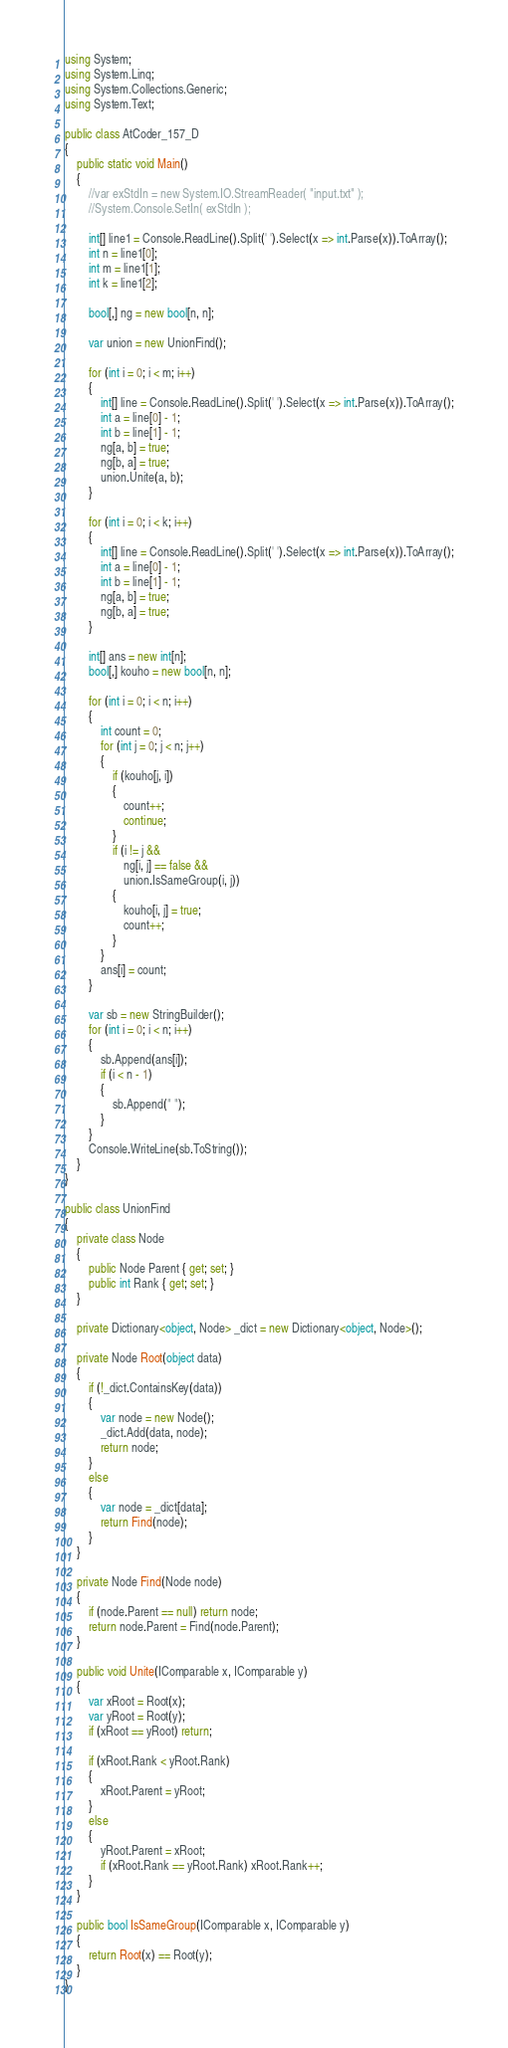<code> <loc_0><loc_0><loc_500><loc_500><_C#_>using System;
using System.Linq;
using System.Collections.Generic;
using System.Text;

public class AtCoder_157_D
{
    public static void Main()
    {
        //var exStdIn = new System.IO.StreamReader( "input.txt" );
        //System.Console.SetIn( exStdIn );

        int[] line1 = Console.ReadLine().Split(' ').Select(x => int.Parse(x)).ToArray();
        int n = line1[0];
        int m = line1[1];
        int k = line1[2];

        bool[,] ng = new bool[n, n];

        var union = new UnionFind();

        for (int i = 0; i < m; i++)
        {
            int[] line = Console.ReadLine().Split(' ').Select(x => int.Parse(x)).ToArray();
            int a = line[0] - 1;
            int b = line[1] - 1;
            ng[a, b] = true;
            ng[b, a] = true;
            union.Unite(a, b);
        }

        for (int i = 0; i < k; i++)
        {
            int[] line = Console.ReadLine().Split(' ').Select(x => int.Parse(x)).ToArray();
            int a = line[0] - 1;
            int b = line[1] - 1;
            ng[a, b] = true;
            ng[b, a] = true;
        }

        int[] ans = new int[n];
        bool[,] kouho = new bool[n, n];

        for (int i = 0; i < n; i++)
        {
            int count = 0;
            for (int j = 0; j < n; j++)
            {
                if (kouho[j, i])
                {
                    count++;
                    continue;
                }
                if (i != j &&
                    ng[i, j] == false &&
                    union.IsSameGroup(i, j))
                {
                    kouho[i, j] = true;
                    count++;
                }
            }
            ans[i] = count;
        }

        var sb = new StringBuilder();
        for (int i = 0; i < n; i++)
        {
            sb.Append(ans[i]);
            if (i < n - 1)
            {
                sb.Append(" ");
            }
        }
        Console.WriteLine(sb.ToString());
    }
}

public class UnionFind
{
    private class Node
    {
        public Node Parent { get; set; }
        public int Rank { get; set; }
    }

    private Dictionary<object, Node> _dict = new Dictionary<object, Node>();

    private Node Root(object data)
    {
        if (!_dict.ContainsKey(data))
        {
            var node = new Node();
            _dict.Add(data, node);
            return node;
        }
        else
        {
            var node = _dict[data];
            return Find(node);
        }
    }

    private Node Find(Node node)
    {
        if (node.Parent == null) return node;
        return node.Parent = Find(node.Parent);
    }

    public void Unite(IComparable x, IComparable y)
    {
        var xRoot = Root(x);
        var yRoot = Root(y);
        if (xRoot == yRoot) return;

        if (xRoot.Rank < yRoot.Rank)
        {
            xRoot.Parent = yRoot;
        }
        else
        {
            yRoot.Parent = xRoot;
            if (xRoot.Rank == yRoot.Rank) xRoot.Rank++;
        }
    }

    public bool IsSameGroup(IComparable x, IComparable y)
    {
        return Root(x) == Root(y);
    }
}
</code> 